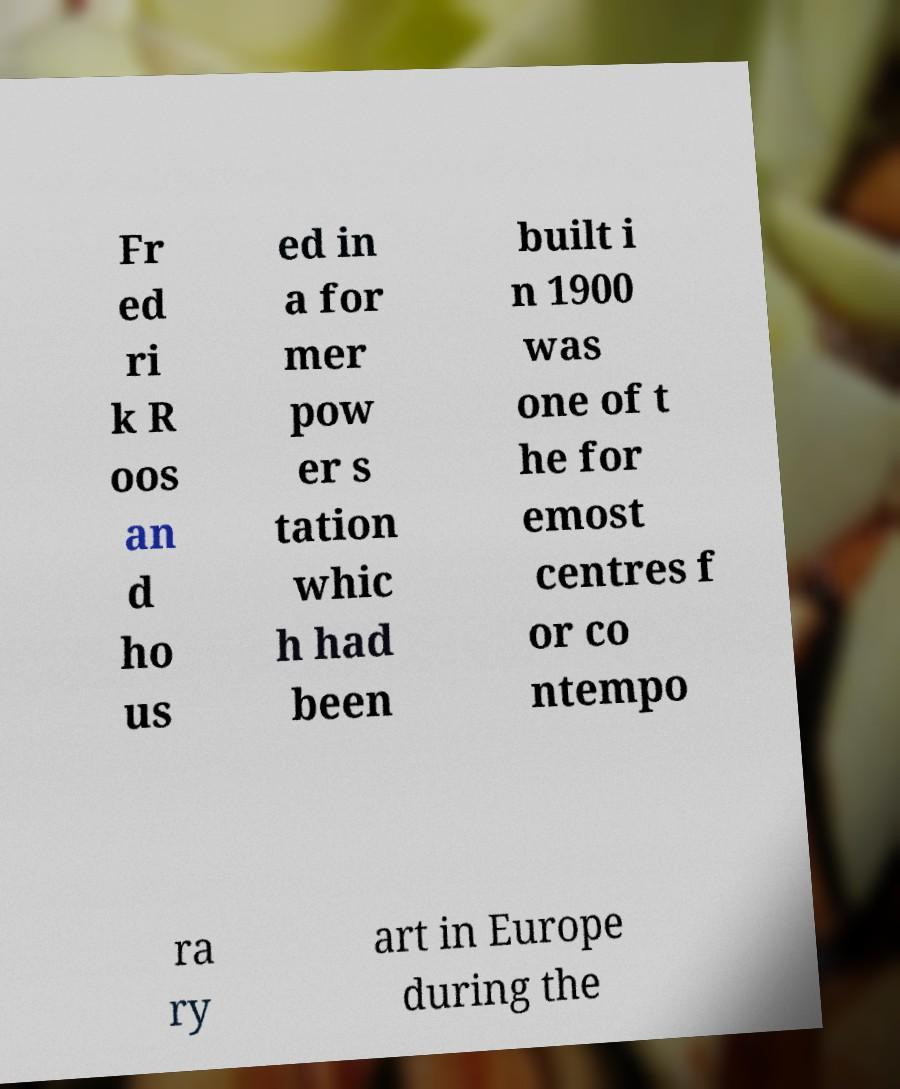Please read and relay the text visible in this image. What does it say? Fr ed ri k R oos an d ho us ed in a for mer pow er s tation whic h had been built i n 1900 was one of t he for emost centres f or co ntempo ra ry art in Europe during the 